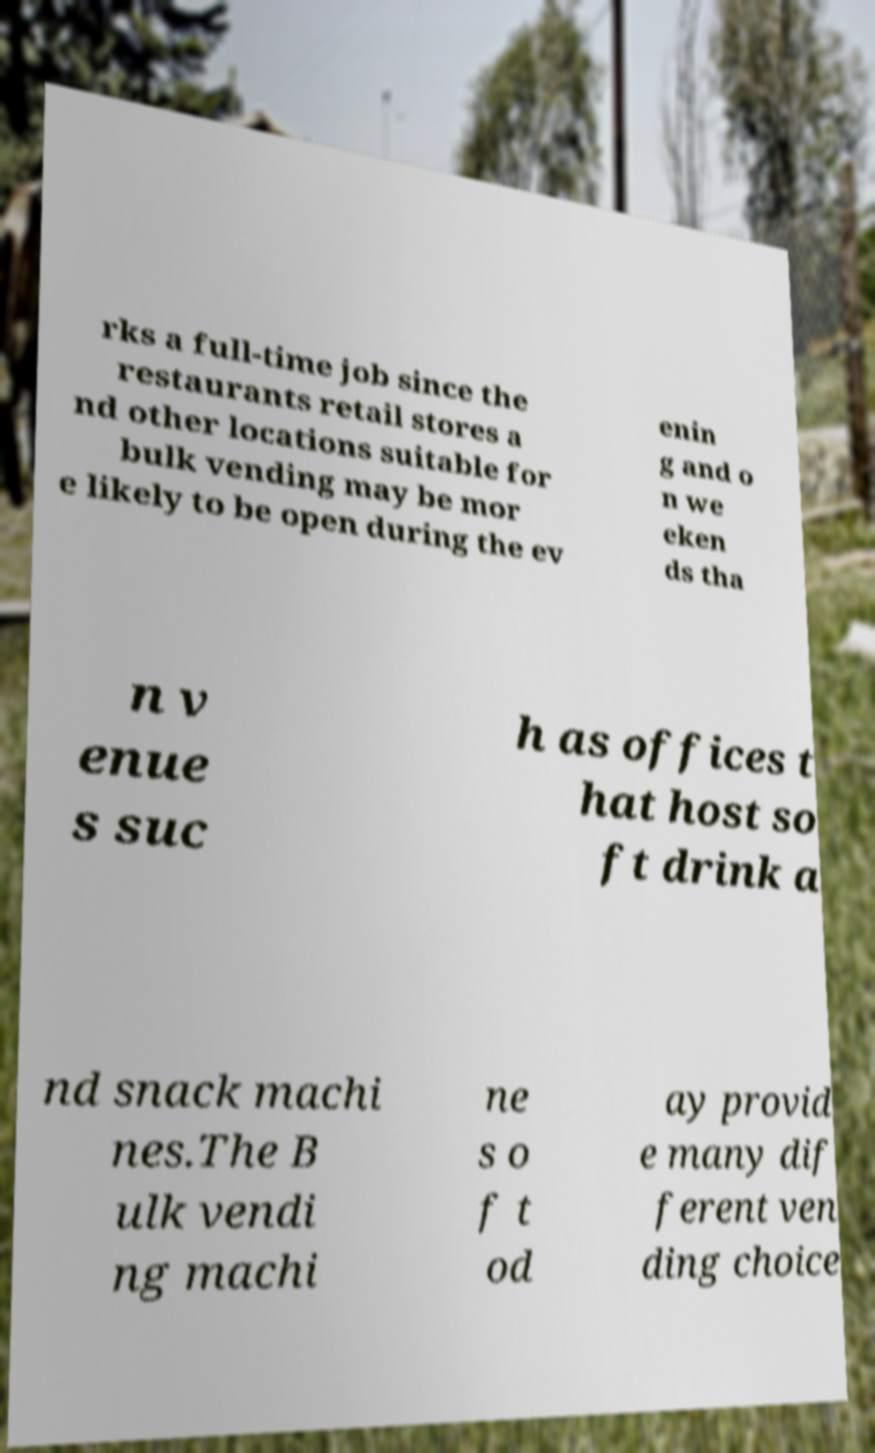Could you assist in decoding the text presented in this image and type it out clearly? rks a full-time job since the restaurants retail stores a nd other locations suitable for bulk vending may be mor e likely to be open during the ev enin g and o n we eken ds tha n v enue s suc h as offices t hat host so ft drink a nd snack machi nes.The B ulk vendi ng machi ne s o f t od ay provid e many dif ferent ven ding choice 